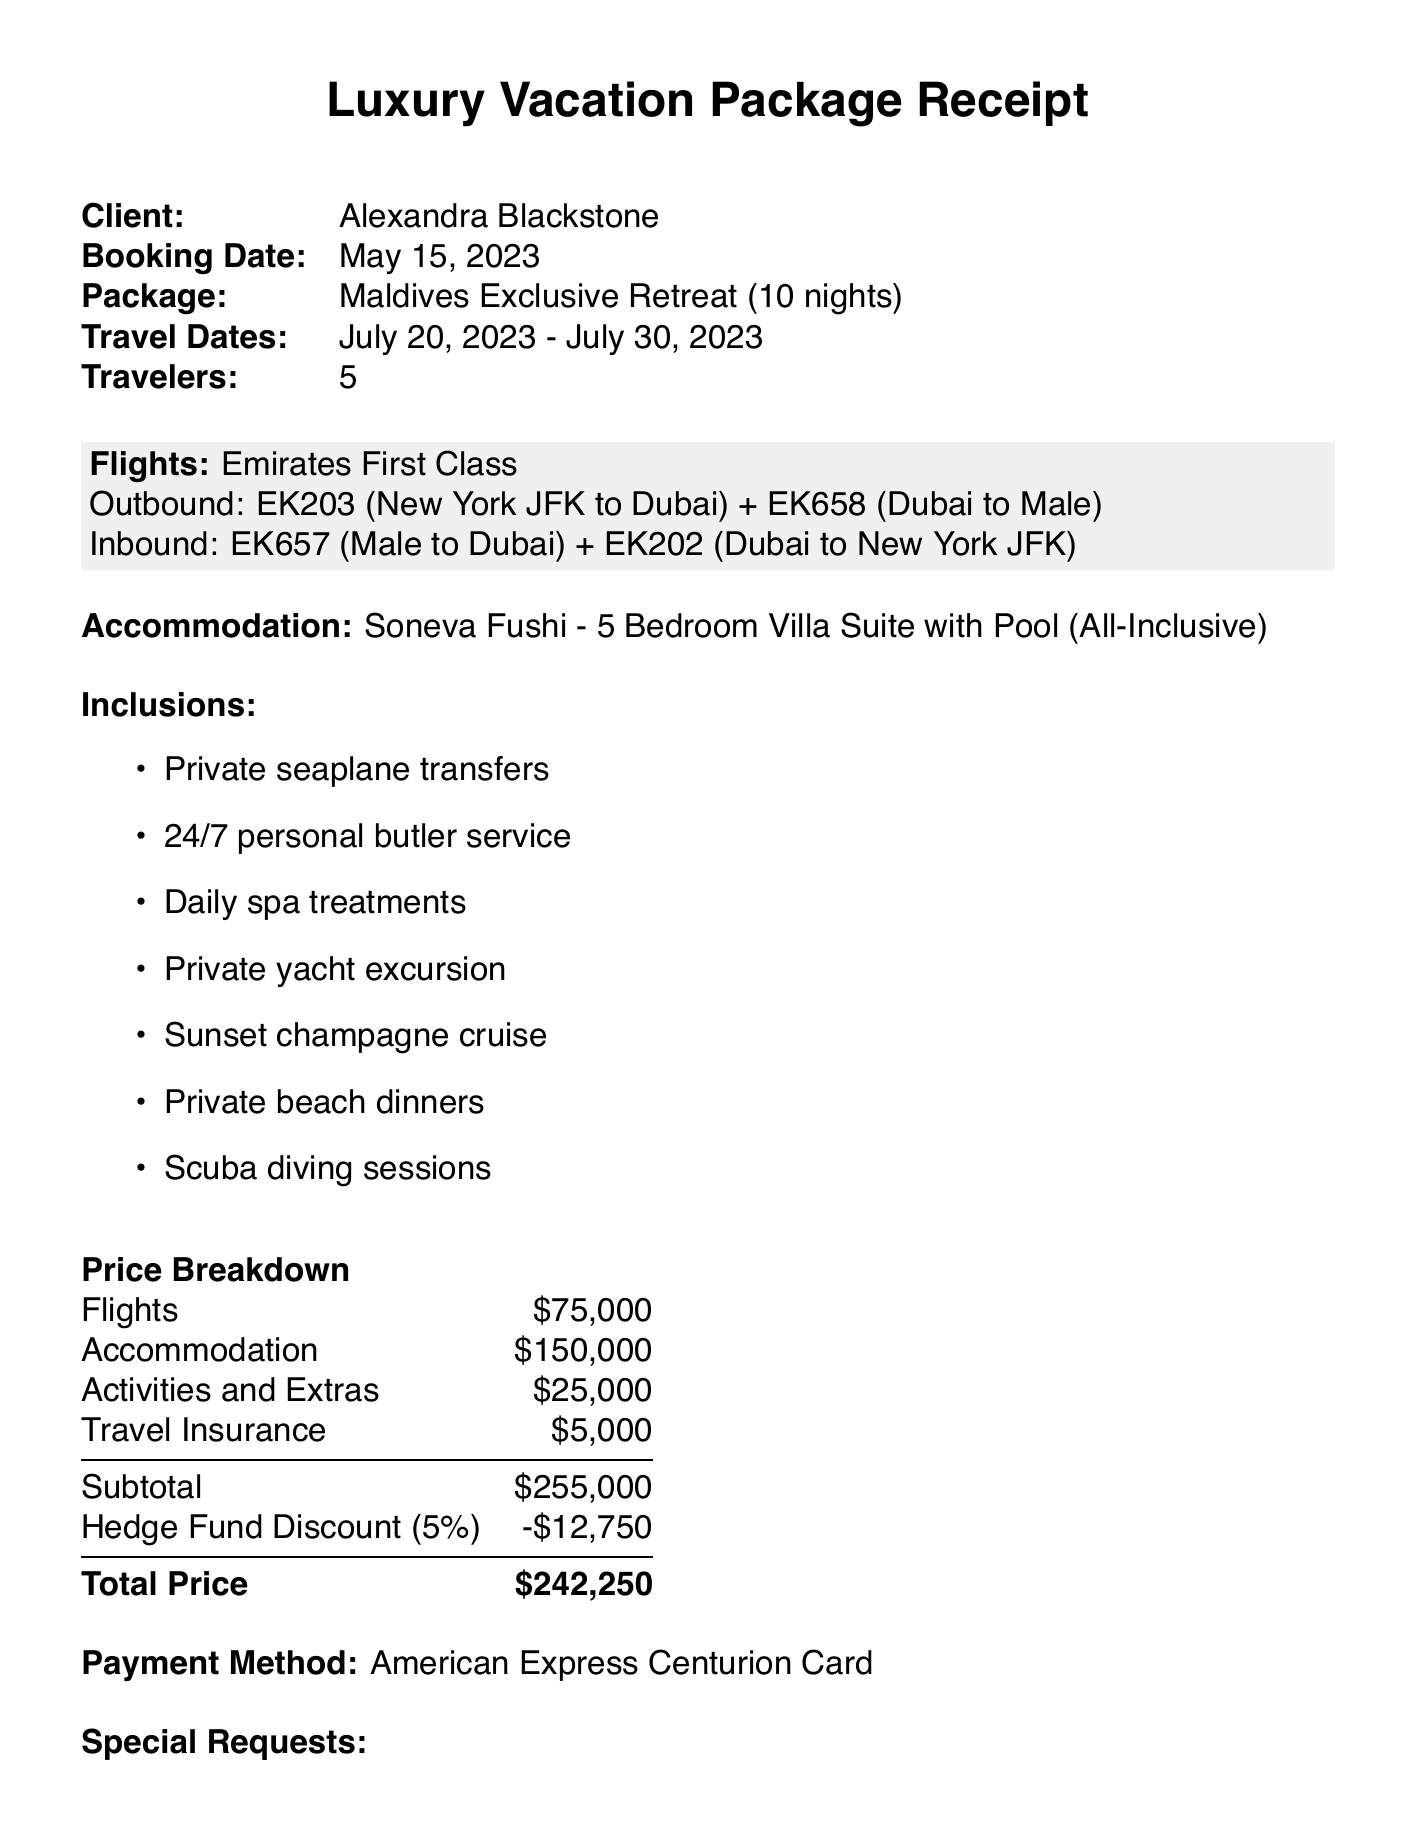What is the booking reference? The booking reference is found in the document displayed at the top under "Booking Ref."
Answer: VLT-23789-HF Who is the client? The client's name is stated clearly on the receipt.
Answer: Alexandra Blackstone What are the travel dates? The travel dates can be found under "Travel Dates," indicating the trip duration.
Answer: July 20, 2023 - July 30, 2023 How many travelers are included in the booking? The number of travelers is mentioned in the document.
Answer: 5 What is the name of the resort? The name of the resort is given under the accommodation section in the document.
Answer: Soneva Fushi What is the total price before the discount? The total price before the discount is found in the price breakdown section.
Answer: 255000 What discount is applied for Blackstone Capital Management clients? The document specifies a discount for clients of Blackstone Capital Management.
Answer: 5% What is the cancellation policy for a full refund? The cancellation policy outlines the conditions for a full refund.
Answer: 60 days before departure What kind of transportation is included? The type of transportation included is listed under the inclusions section of the document.
Answer: Private seaplane transfers Who is the travel advisor? The travel advisor's name is provided in the document.
Answer: Emily Thompson 